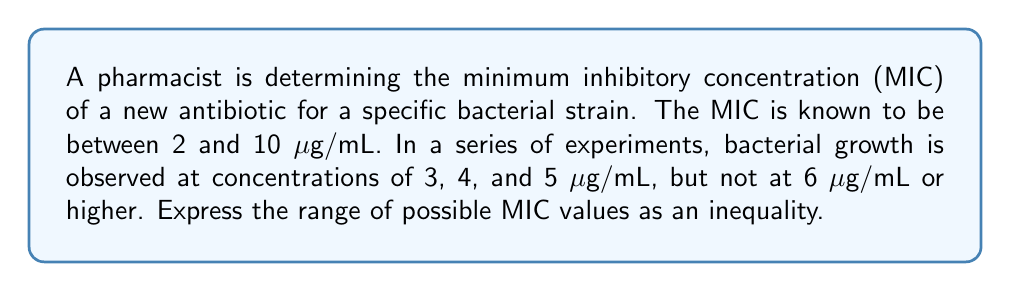Teach me how to tackle this problem. 1) The MIC is defined as the lowest concentration of an antibiotic that prevents visible growth of bacteria.

2) We know that:
   - Growth occurs at 5 μg/mL and below
   - No growth occurs at 6 μg/mL and above

3) Therefore, the MIC must be greater than 5 μg/mL (as growth still occurs at this concentration) and less than or equal to 6 μg/mL (as this is the lowest concentration where no growth is observed).

4) We can express this as an inequality:

   $$ 5 < \text{MIC} \leq 6 $$

5) This inequality satisfies the initial condition that the MIC is between 2 and 10 μg/mL.

6) In the context of antibiotic resistance, this precise determination of MIC is crucial for appropriate dosing and preventing the development of resistant bacterial strains.
Answer: $$ 5 < \text{MIC} \leq 6 $$ 